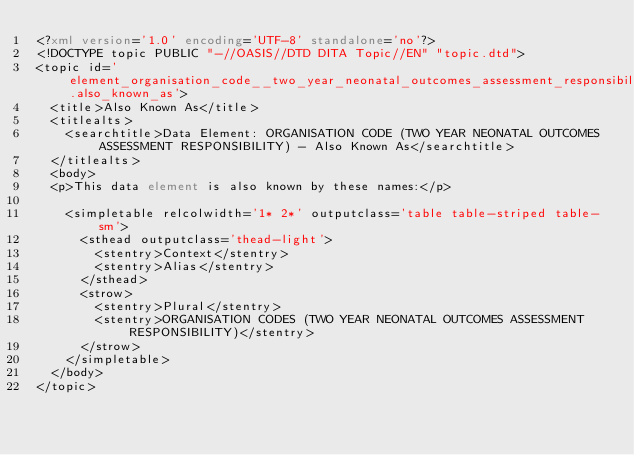Convert code to text. <code><loc_0><loc_0><loc_500><loc_500><_XML_><?xml version='1.0' encoding='UTF-8' standalone='no'?>
<!DOCTYPE topic PUBLIC "-//OASIS//DTD DITA Topic//EN" "topic.dtd">
<topic id='element_organisation_code__two_year_neonatal_outcomes_assessment_responsibility_.also_known_as'>
  <title>Also Known As</title>
  <titlealts>
    <searchtitle>Data Element: ORGANISATION CODE (TWO YEAR NEONATAL OUTCOMES ASSESSMENT RESPONSIBILITY) - Also Known As</searchtitle>
  </titlealts>
  <body>
  <p>This data element is also known by these names:</p>

    <simpletable relcolwidth='1* 2*' outputclass='table table-striped table-sm'>
      <sthead outputclass='thead-light'>
        <stentry>Context</stentry>
        <stentry>Alias</stentry>
      </sthead>
      <strow>
        <stentry>Plural</stentry>
        <stentry>ORGANISATION CODES (TWO YEAR NEONATAL OUTCOMES ASSESSMENT RESPONSIBILITY)</stentry>
      </strow>
    </simpletable>
  </body>
</topic></code> 